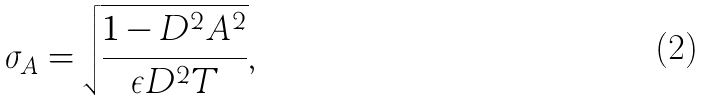Convert formula to latex. <formula><loc_0><loc_0><loc_500><loc_500>\sigma _ { A } = \sqrt { \frac { 1 - D ^ { 2 } A ^ { 2 } } { \epsilon D ^ { 2 } T } } ,</formula> 